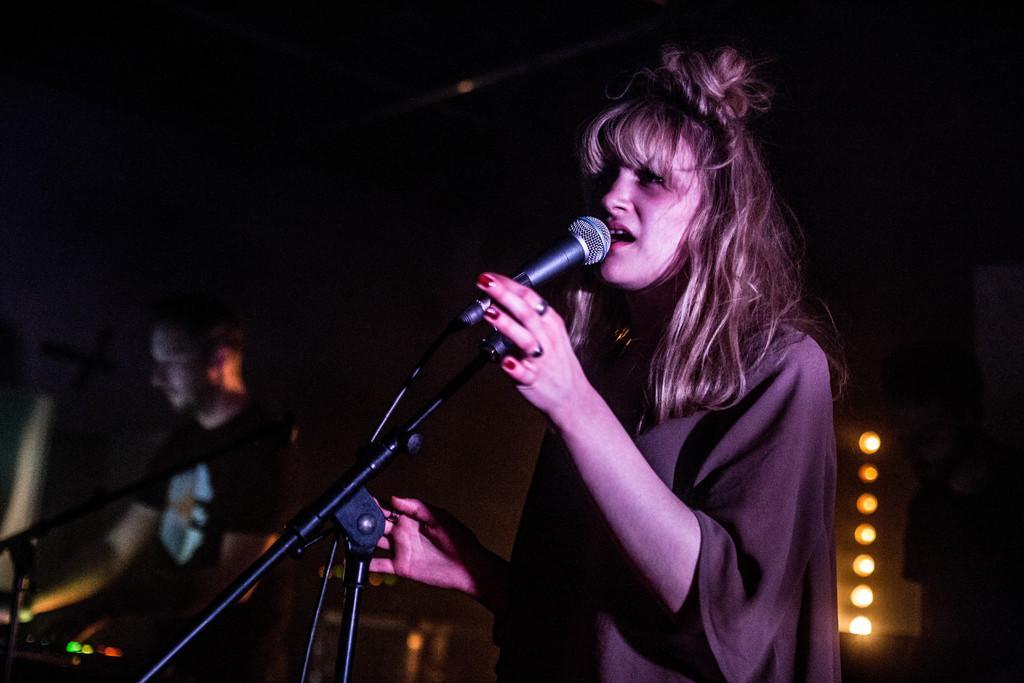Can you describe this image briefly? In this image, there are a few people. We can also see some microphones. We can see the background and some lights. 